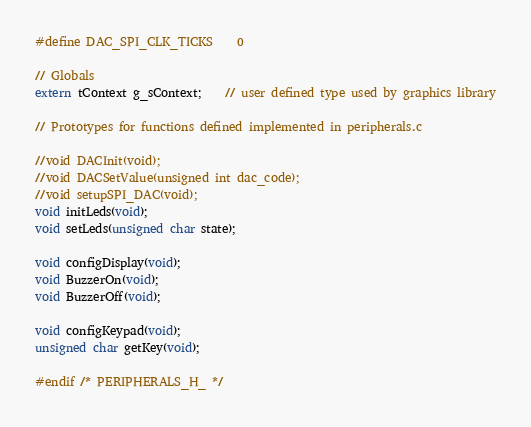Convert code to text. <code><loc_0><loc_0><loc_500><loc_500><_C_>#define DAC_SPI_CLK_TICKS	0

// Globals
extern tContext g_sContext;	// user defined type used by graphics library

// Prototypes for functions defined implemented in peripherals.c

//void DACInit(void);
//void DACSetValue(unsigned int dac_code);
//void setupSPI_DAC(void);
void initLeds(void);
void setLeds(unsigned char state);

void configDisplay(void);
void BuzzerOn(void);
void BuzzerOff(void);

void configKeypad(void);
unsigned char getKey(void);

#endif /* PERIPHERALS_H_ */
</code> 